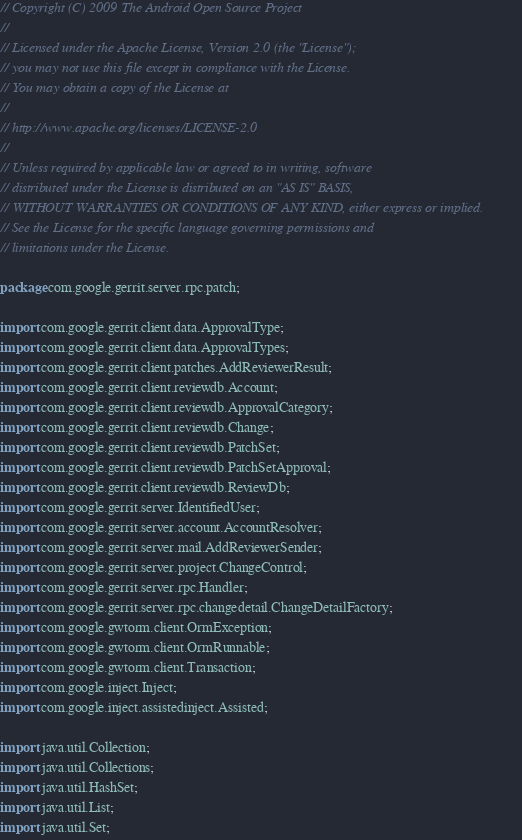<code> <loc_0><loc_0><loc_500><loc_500><_Java_>// Copyright (C) 2009 The Android Open Source Project
//
// Licensed under the Apache License, Version 2.0 (the "License");
// you may not use this file except in compliance with the License.
// You may obtain a copy of the License at
//
// http://www.apache.org/licenses/LICENSE-2.0
//
// Unless required by applicable law or agreed to in writing, software
// distributed under the License is distributed on an "AS IS" BASIS,
// WITHOUT WARRANTIES OR CONDITIONS OF ANY KIND, either express or implied.
// See the License for the specific language governing permissions and
// limitations under the License.

package com.google.gerrit.server.rpc.patch;

import com.google.gerrit.client.data.ApprovalType;
import com.google.gerrit.client.data.ApprovalTypes;
import com.google.gerrit.client.patches.AddReviewerResult;
import com.google.gerrit.client.reviewdb.Account;
import com.google.gerrit.client.reviewdb.ApprovalCategory;
import com.google.gerrit.client.reviewdb.Change;
import com.google.gerrit.client.reviewdb.PatchSet;
import com.google.gerrit.client.reviewdb.PatchSetApproval;
import com.google.gerrit.client.reviewdb.ReviewDb;
import com.google.gerrit.server.IdentifiedUser;
import com.google.gerrit.server.account.AccountResolver;
import com.google.gerrit.server.mail.AddReviewerSender;
import com.google.gerrit.server.project.ChangeControl;
import com.google.gerrit.server.rpc.Handler;
import com.google.gerrit.server.rpc.changedetail.ChangeDetailFactory;
import com.google.gwtorm.client.OrmException;
import com.google.gwtorm.client.OrmRunnable;
import com.google.gwtorm.client.Transaction;
import com.google.inject.Inject;
import com.google.inject.assistedinject.Assisted;

import java.util.Collection;
import java.util.Collections;
import java.util.HashSet;
import java.util.List;
import java.util.Set;
</code> 